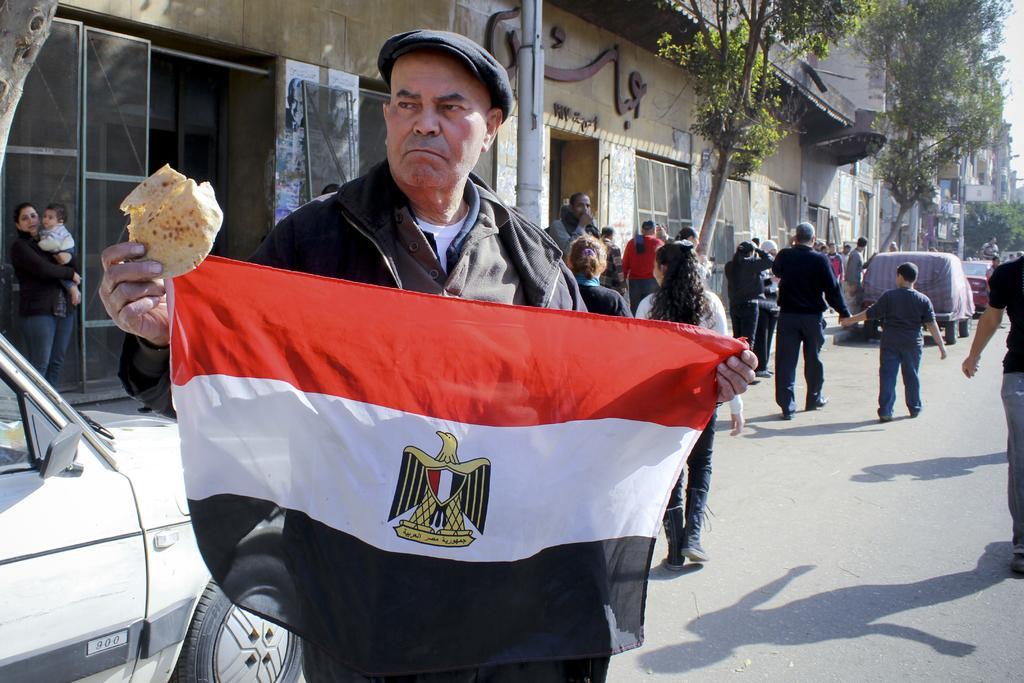Could you give a brief overview of what you see in this image? In this image we can see a man holding the food item and also the flag. In the background we can see the people on the road. We can also see the vehicles, buildings, trees and also the poles. Sky is also visible. 